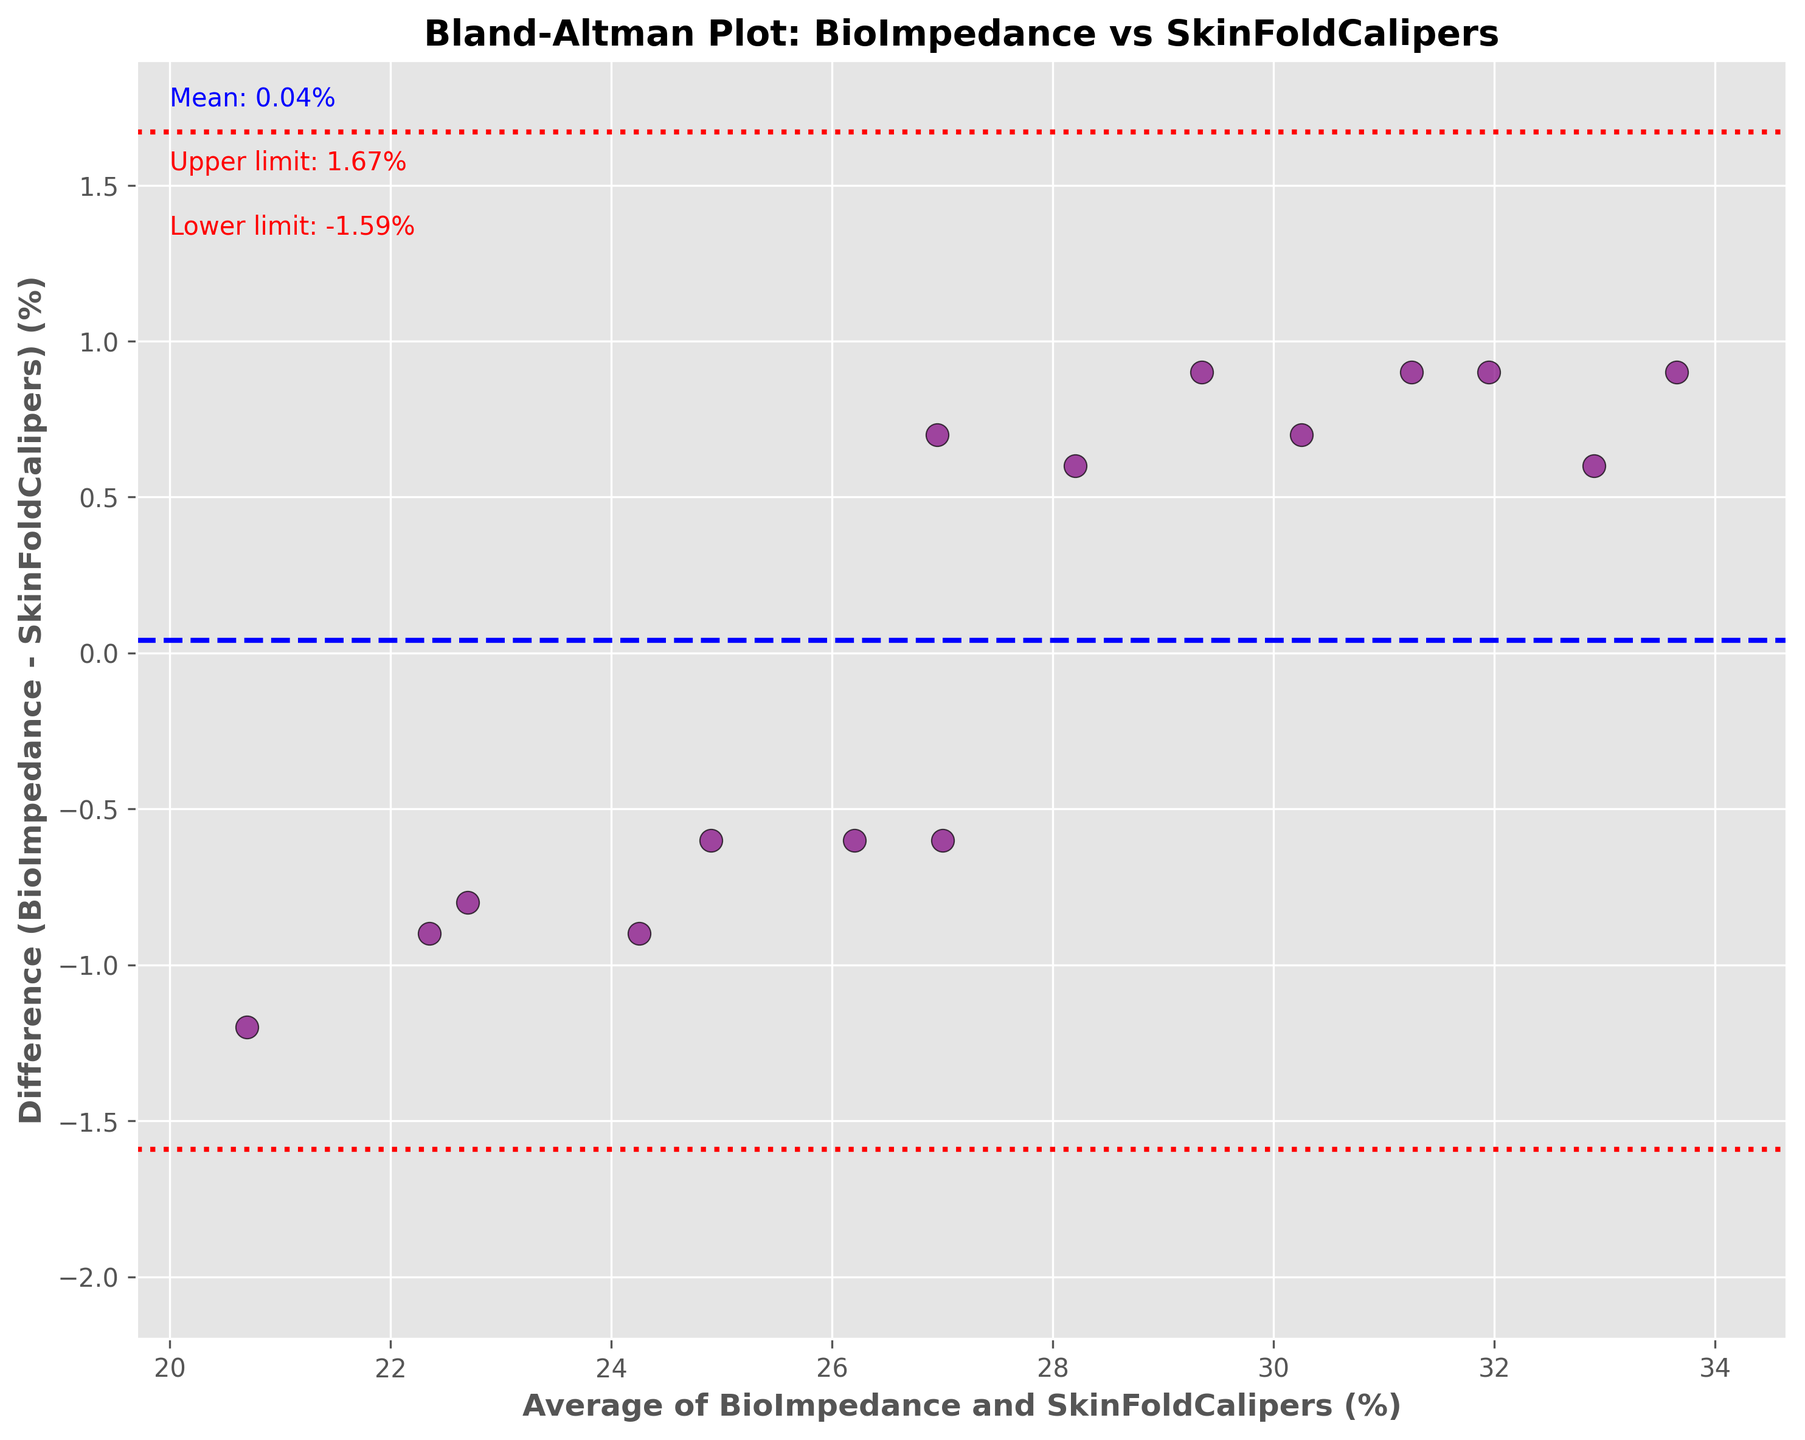What is the title of the plot? The title is usually found at the top of the figure and gives a summary of what the plot represents. Here, the title should describe the comparison being made.
Answer: Bland-Altman Plot: BioImpedance vs SkinFoldCalipers What are the x-axis and y-axis labels? The axis labels provide information about what is being measured on each axis. These labels are found next to the axes.
Answer: x-axis: Average of BioImpedance and SkinFoldCalipers (%), y-axis: Difference (BioImpedance - SkinFoldCalipers) (%) How many data points are there in the plot? Each data point in a Bland-Altman plot represents an individual subject's average measurement and difference in measurements. By counting these points, you determine the total number.
Answer: 15 What color are the upper and lower limit lines? The color of lines representing upper and lower limits can be found by visually inspecting the plot. These lines are often annotated with numerical values as well.
Answer: Red What is the range of the x-axis? To find the x-axis range, observe the minimum and maximum values marked along the horizontal axis. Ensure to consider the axis limits set by the plot's author.
Answer: 20.7 to 33.65 What is the mean difference between BioImpedance and SkinFoldCalipers measurements? The mean difference is indicated by a horizontal line, often with an annotation specifying its value. Observation of this annotation yields the desired value.
Answer: 0.07% Are there more positive or negative differences between the BioImpedance and SkinFoldCalipers measurements? By counting the data points above and below the zero line (mean difference), we determine which category has more occurrences.
Answer: Positive Which subject has the highest average measurement? The average measurement for each subject is plotted along the x-axis. Identifying the furthest right data point determines the subject with the highest average.
Answer: Jessica What are the upper and lower limits of agreement? These limits are represented by two horizontal lines, each with annotative values typically provided for clarity.
Answer: Upper limit: 2.20%, Lower limit: -2.06% If a new subject had an average measurement of 25.0%, what would be the expected difference range? Based on the limits of agreement, any new data point within this average range should fall between these pre-defined limits, ensuring consistent interpretation.
Answer: -2.06% to 2.20% 